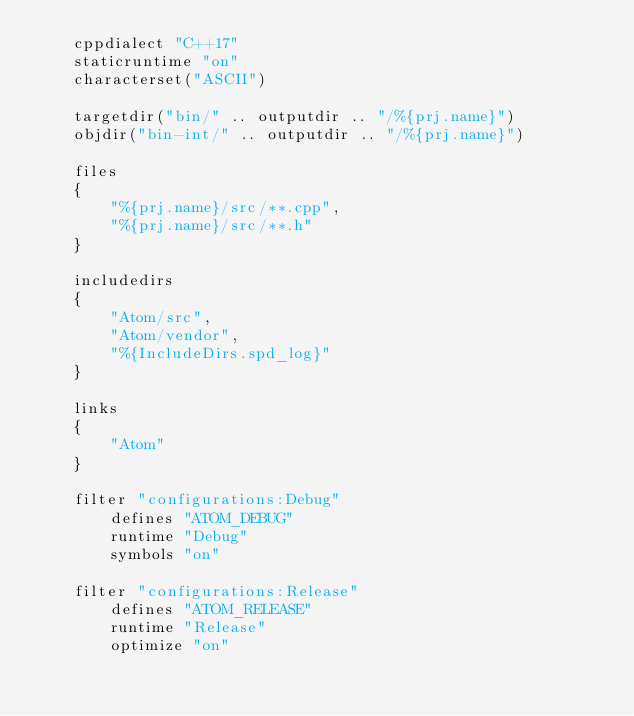Convert code to text. <code><loc_0><loc_0><loc_500><loc_500><_Lua_>	cppdialect "C++17"
	staticruntime "on"
	characterset("ASCII")

	targetdir("bin/" .. outputdir .. "/%{prj.name}")
	objdir("bin-int/" .. outputdir .. "/%{prj.name}")

	files
	{
		"%{prj.name}/src/**.cpp",
		"%{prj.name}/src/**.h"
	}

	includedirs
	{
		"Atom/src",
		"Atom/vendor",
		"%{IncludeDirs.spd_log}"
	}

	links
	{
		"Atom"
	}

	filter "configurations:Debug"
		defines "ATOM_DEBUG"
		runtime "Debug"
		symbols "on"

	filter "configurations:Release"
		defines "ATOM_RELEASE"
		runtime "Release"
		optimize "on"
</code> 